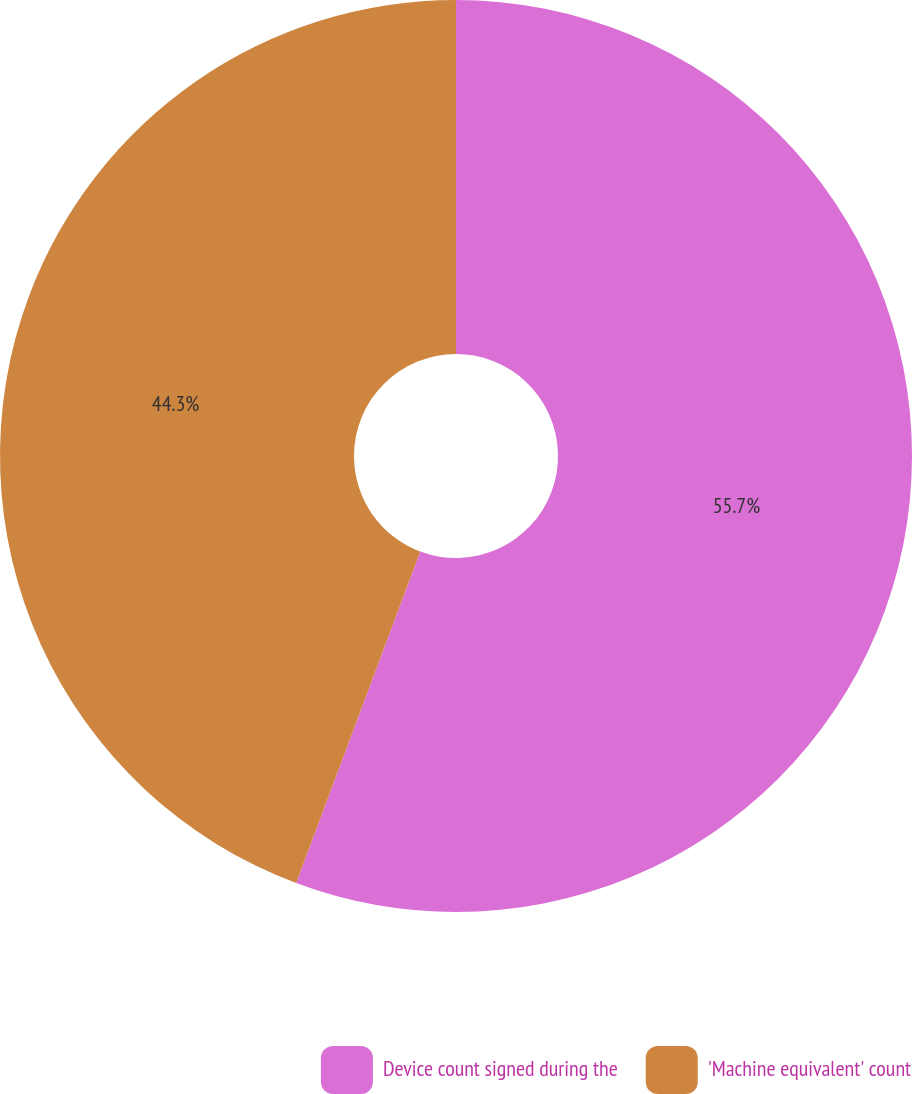Convert chart. <chart><loc_0><loc_0><loc_500><loc_500><pie_chart><fcel>Device count signed during the<fcel>'Machine equivalent' count<nl><fcel>55.7%<fcel>44.3%<nl></chart> 